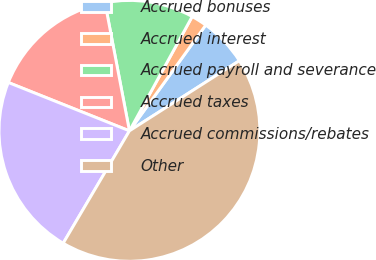<chart> <loc_0><loc_0><loc_500><loc_500><pie_chart><fcel>Accrued bonuses<fcel>Accrued interest<fcel>Accrued payroll and severance<fcel>Accrued taxes<fcel>Accrued commissions/rebates<fcel>Other<nl><fcel>6.01%<fcel>1.96%<fcel>10.99%<fcel>15.95%<fcel>22.57%<fcel>42.52%<nl></chart> 